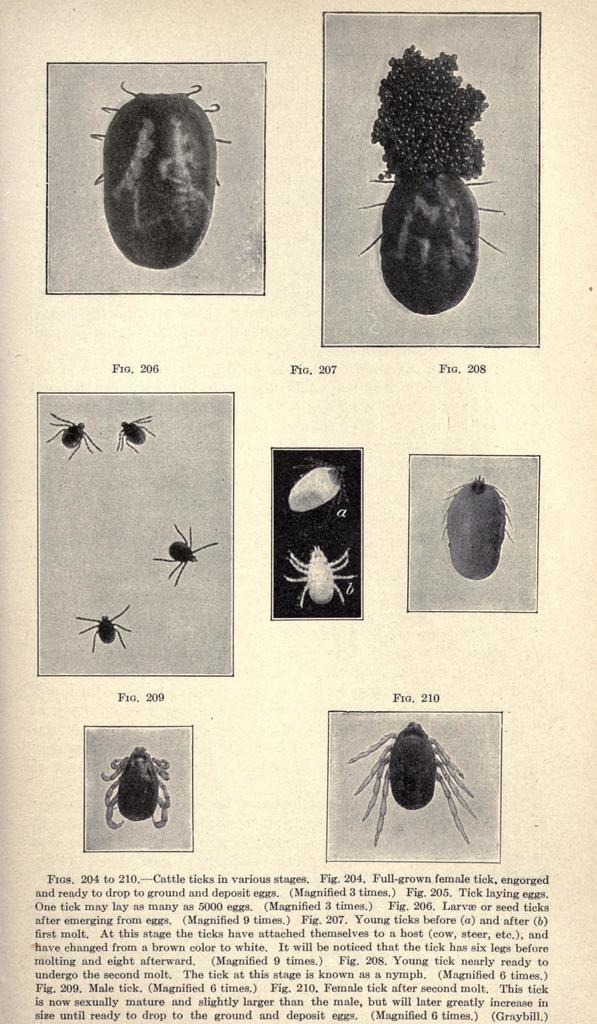What is depicted in the image in terms of living organisms? The image contains different stages of an insect. Are there any words or phrases written on the image? Yes, there is text written on the image. What is the color scheme of the image? The image is in black and white. How many bulbs are hanging from the ceiling in the image? There are no bulbs present in the image; it features an insect and its different stages, along with text and a black and white color scheme. What type of corn is growing in the image? There is no corn present in the image. 